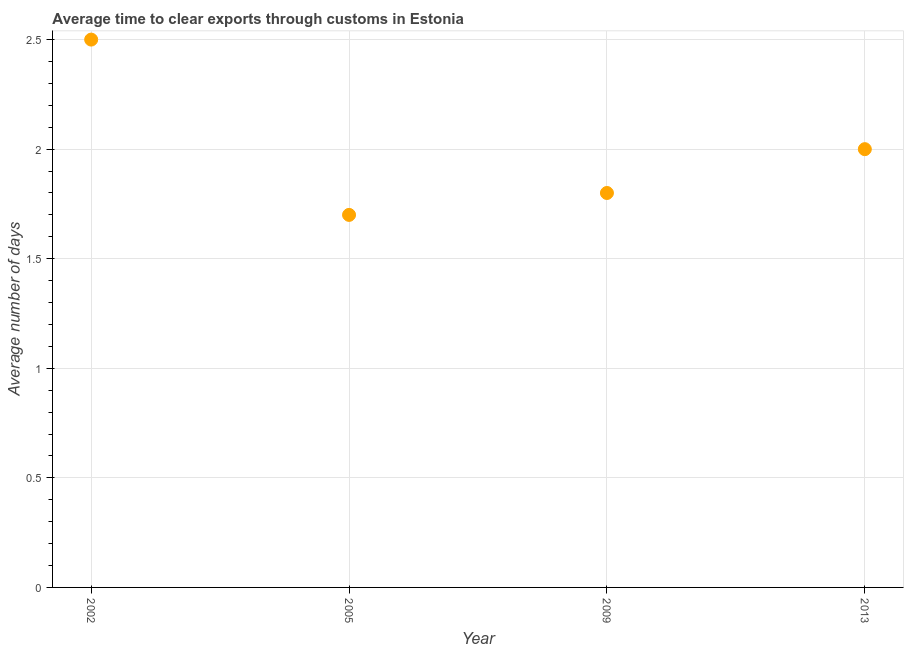What is the time to clear exports through customs in 2005?
Your answer should be compact. 1.7. Across all years, what is the minimum time to clear exports through customs?
Provide a short and direct response. 1.7. What is the sum of the time to clear exports through customs?
Ensure brevity in your answer.  8. What is the difference between the time to clear exports through customs in 2002 and 2013?
Your answer should be compact. 0.5. What is the average time to clear exports through customs per year?
Your answer should be very brief. 2. Do a majority of the years between 2013 and 2005 (inclusive) have time to clear exports through customs greater than 0.4 days?
Make the answer very short. No. What is the ratio of the time to clear exports through customs in 2005 to that in 2013?
Offer a terse response. 0.85. Is the time to clear exports through customs in 2002 less than that in 2013?
Make the answer very short. No. Is the difference between the time to clear exports through customs in 2002 and 2005 greater than the difference between any two years?
Offer a terse response. Yes. What is the difference between the highest and the lowest time to clear exports through customs?
Provide a short and direct response. 0.8. In how many years, is the time to clear exports through customs greater than the average time to clear exports through customs taken over all years?
Ensure brevity in your answer.  1. Does the time to clear exports through customs monotonically increase over the years?
Your response must be concise. No. How many years are there in the graph?
Offer a very short reply. 4. What is the difference between two consecutive major ticks on the Y-axis?
Give a very brief answer. 0.5. Are the values on the major ticks of Y-axis written in scientific E-notation?
Offer a very short reply. No. Does the graph contain any zero values?
Your response must be concise. No. Does the graph contain grids?
Keep it short and to the point. Yes. What is the title of the graph?
Your answer should be compact. Average time to clear exports through customs in Estonia. What is the label or title of the Y-axis?
Your answer should be compact. Average number of days. What is the Average number of days in 2002?
Offer a terse response. 2.5. What is the Average number of days in 2005?
Provide a short and direct response. 1.7. What is the Average number of days in 2009?
Offer a terse response. 1.8. What is the difference between the Average number of days in 2002 and 2013?
Your response must be concise. 0.5. What is the difference between the Average number of days in 2005 and 2009?
Ensure brevity in your answer.  -0.1. What is the ratio of the Average number of days in 2002 to that in 2005?
Offer a very short reply. 1.47. What is the ratio of the Average number of days in 2002 to that in 2009?
Your answer should be compact. 1.39. What is the ratio of the Average number of days in 2005 to that in 2009?
Offer a very short reply. 0.94. What is the ratio of the Average number of days in 2005 to that in 2013?
Keep it short and to the point. 0.85. 